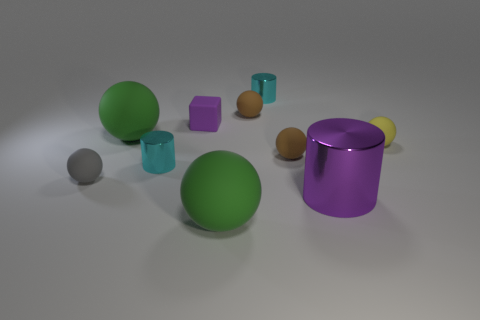The big matte object that is behind the tiny cyan object that is in front of the brown rubber ball in front of the matte block is what shape?
Your answer should be very brief. Sphere. What shape is the purple rubber object that is the same size as the yellow ball?
Offer a very short reply. Cube. What number of tiny metal cylinders are in front of the cyan cylinder to the right of the ball that is in front of the big purple object?
Provide a succinct answer. 1. Are there more large shiny objects on the left side of the big metallic cylinder than purple shiny cylinders left of the small gray ball?
Your answer should be very brief. No. What number of small gray matte objects have the same shape as the tiny yellow thing?
Your answer should be compact. 1. How many objects are either metal cylinders in front of the gray thing or large green rubber objects behind the gray rubber object?
Make the answer very short. 2. There is a small brown sphere behind the big green ball on the left side of the large rubber ball that is in front of the big purple thing; what is its material?
Your answer should be very brief. Rubber. Is the color of the small metallic cylinder in front of the yellow matte ball the same as the tiny rubber block?
Your answer should be very brief. No. What is the material of the tiny ball that is in front of the small yellow ball and on the right side of the small gray rubber thing?
Offer a terse response. Rubber. Is there a purple rubber cube of the same size as the gray matte ball?
Give a very brief answer. Yes. 